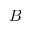<formula> <loc_0><loc_0><loc_500><loc_500>B</formula> 